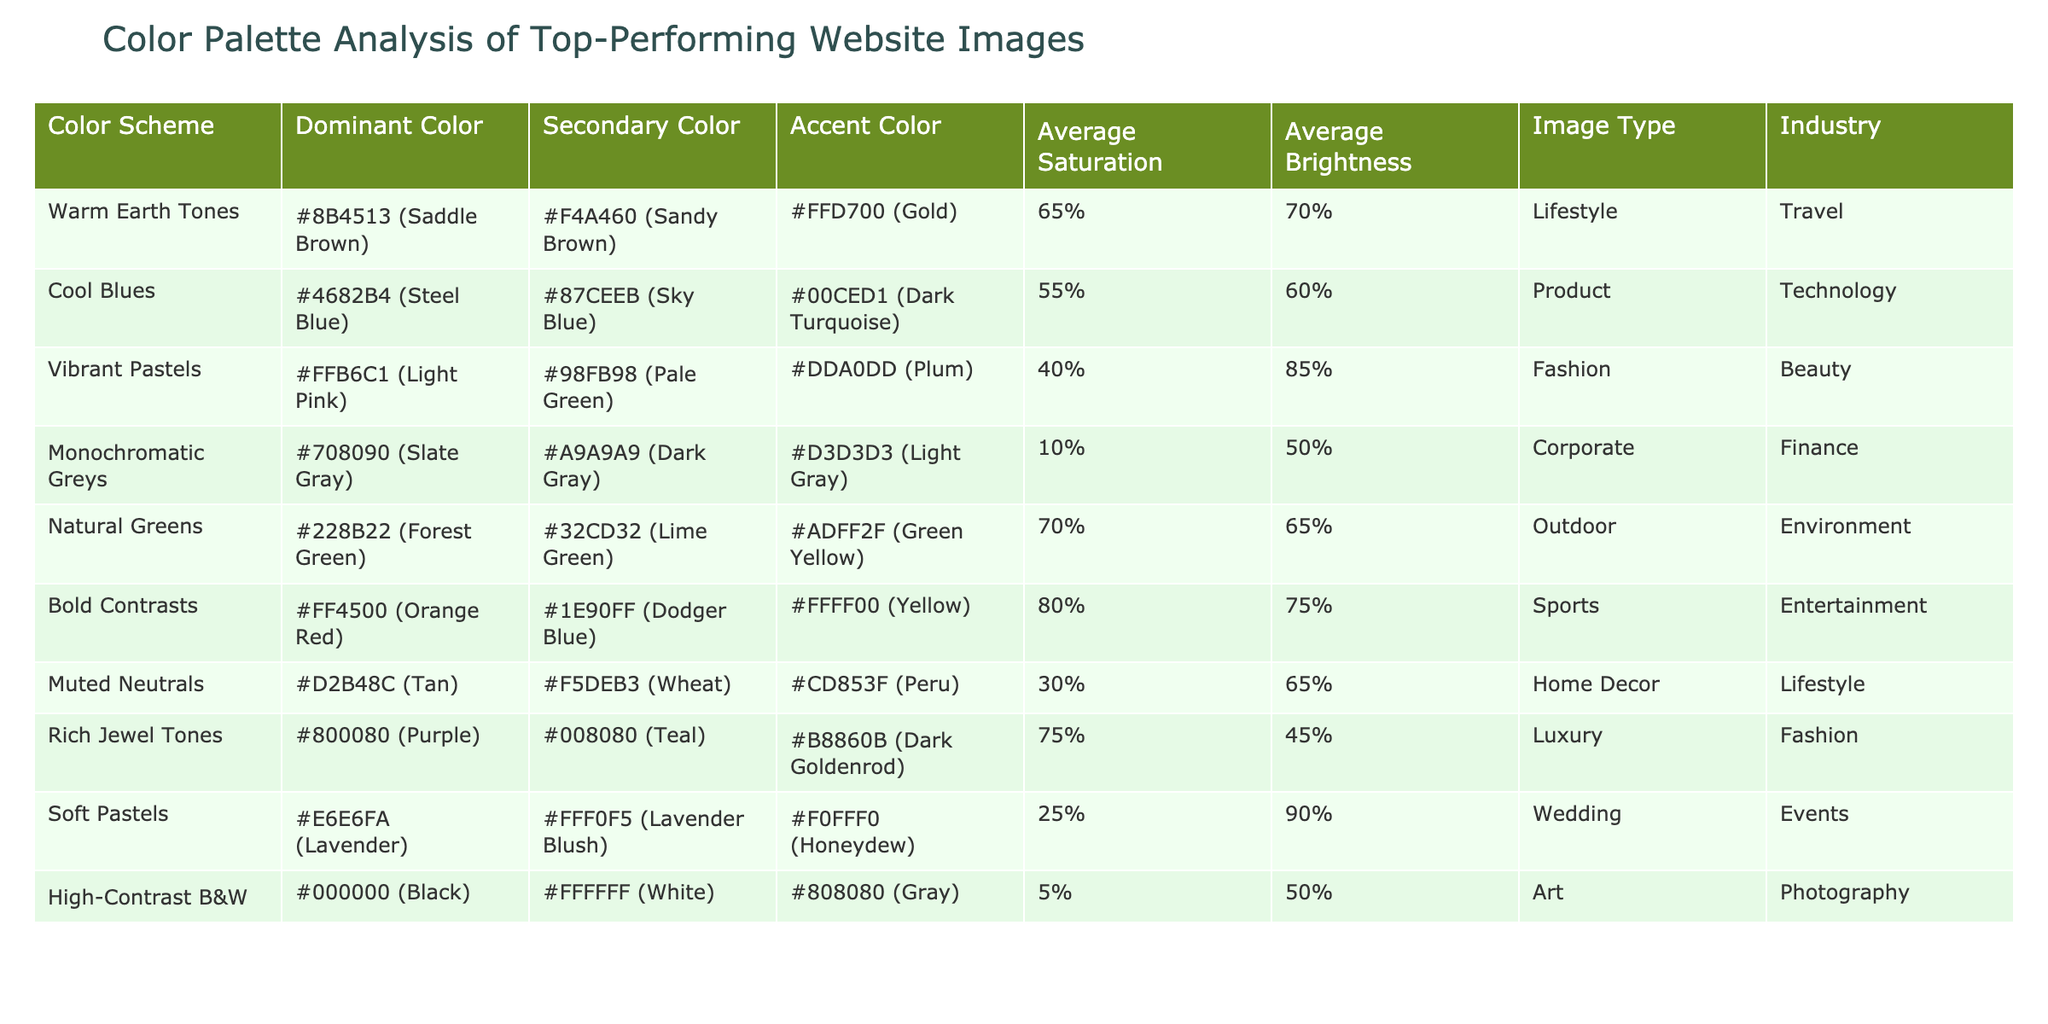What is the dominant color of the "Bold Contrasts" color scheme? By referring to the table, I see that the dominant color for "Bold Contrasts" is listed as #FF4500 (Orange Red).
Answer: #FF4500 (Orange Red) Which color scheme has the highest average saturation? Examining the "Average Saturation" column for all color schemes, "Bold Contrasts" has the highest value at 80%.
Answer: Bold Contrasts Is the average brightness of "High-Contrast B&W" greater than that of "Warm Earth Tones"? By looking at the "Average Brightness" values, "High-Contrast B&W" is 50% and "Warm Earth Tones" is 70%. 50% is not greater than 70%, so the statement is false.
Answer: No What is the accent color for the "Vibrant Pastels" color scheme? I can find the accent color for "Vibrant Pastels" directly in the table, which is listed as #DDA0DD (Plum).
Answer: #DDA0DD (Plum) Which industry uses the “Natural Greens” color palette? The industry associated with the "Natural Greens" color scheme is "Environment," as indicated in the table.
Answer: Environment What is the average brightness of all the color schemes in the table? I will add up all the average brightness values: 70% + 60% + 85% + 50% + 65% + 75% + 65% + 45% + 90% + 50% =  675%. There are 10 color schemes, so the average brightness is 675% / 10 = 67.5%.
Answer: 67.5% Which color scheme has the lowest average saturation? By reviewing the "Average Saturation" column, I see that "High-Contrast B&W" has the lowest average saturation at 5%.
Answer: High-Contrast B&W Is the secondary color for "Soft Pastels" brighter than the secondary color for "Muted Neutrals"? The secondary color for "Soft Pastels" is #FFF0F5 (Lavender Blush), and for "Muted Neutrals" it is #F5DEB3 (Wheat). Both colors are pastel, but I can compare their average brightness values: 90% for Soft Pastels and 65% for Muted Neutrals. 90% is brighter than 65%, making the statement true.
Answer: Yes What color scheme is categorized under the "Wedding" industry? Based on the table, the color scheme categorized under the "Wedding" industry is "Soft Pastels."
Answer: Soft Pastels Which image type has the color scheme with the highest average brightness? Analyzing the "Average Brightness" column, "Soft Pastels" has the highest value at 90%, which corresponds to the image type "Wedding."
Answer: Wedding 